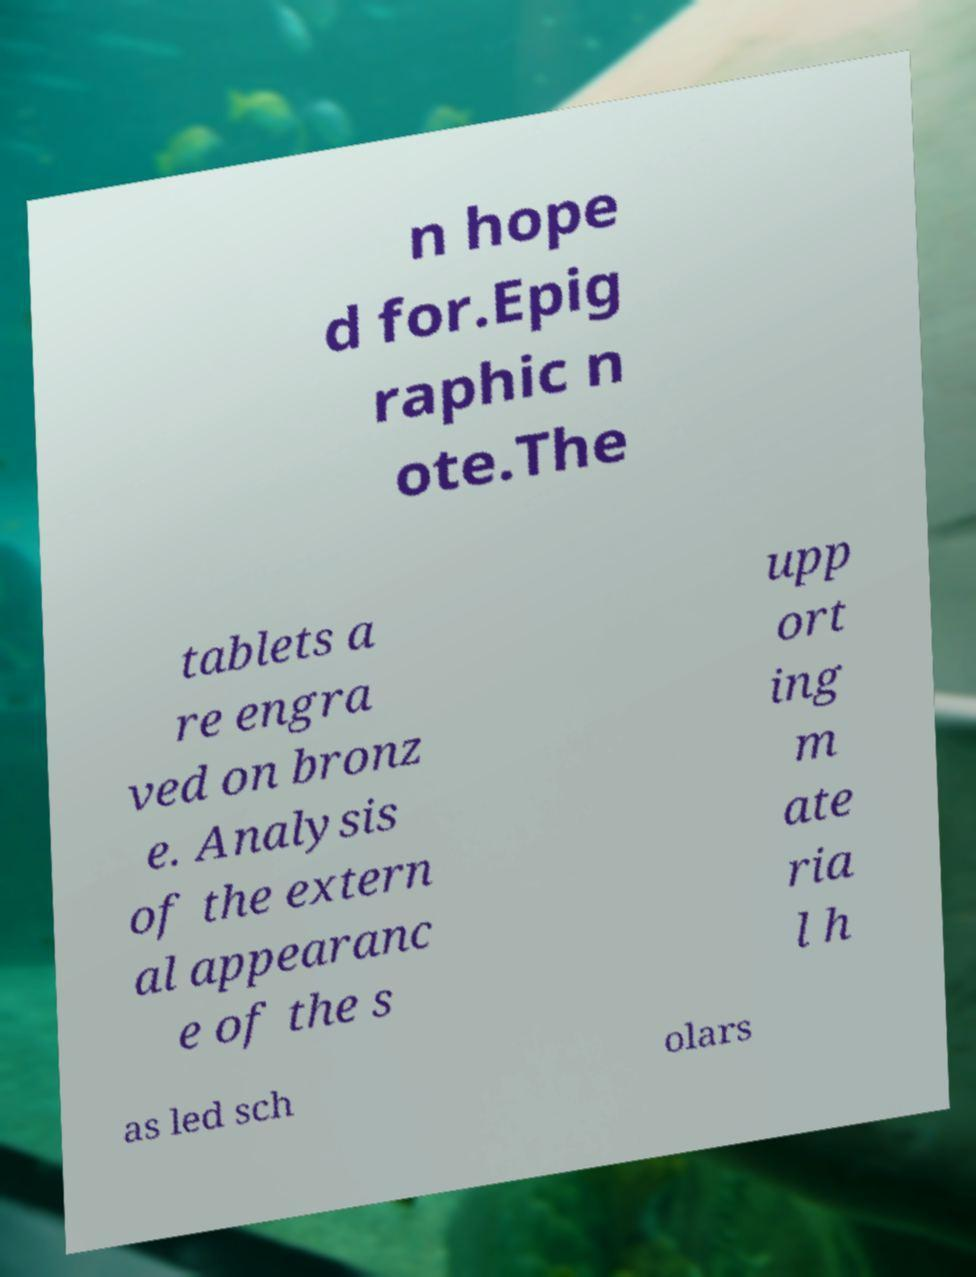I need the written content from this picture converted into text. Can you do that? n hope d for.Epig raphic n ote.The tablets a re engra ved on bronz e. Analysis of the extern al appearanc e of the s upp ort ing m ate ria l h as led sch olars 